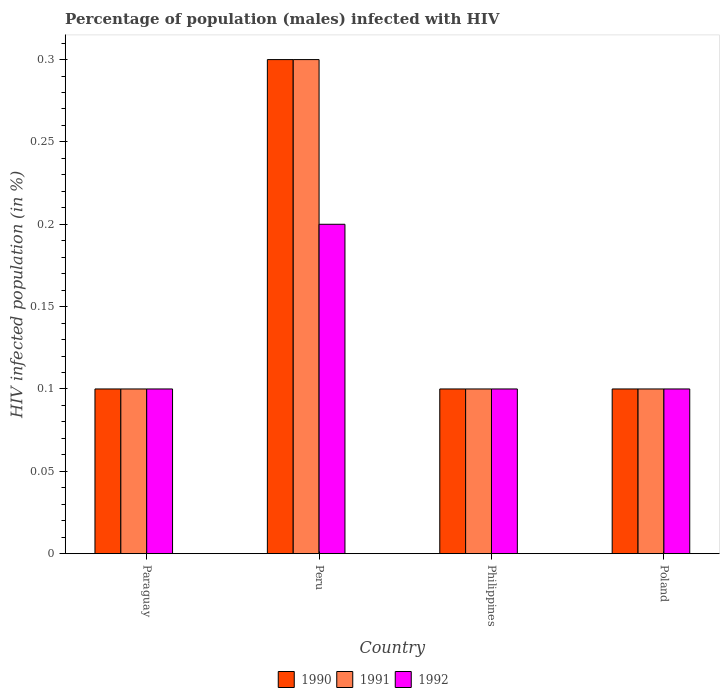How many different coloured bars are there?
Ensure brevity in your answer.  3. How many groups of bars are there?
Keep it short and to the point. 4. Are the number of bars per tick equal to the number of legend labels?
Keep it short and to the point. Yes. How many bars are there on the 3rd tick from the left?
Ensure brevity in your answer.  3. How many bars are there on the 4th tick from the right?
Offer a terse response. 3. What is the label of the 1st group of bars from the left?
Offer a terse response. Paraguay. In how many cases, is the number of bars for a given country not equal to the number of legend labels?
Your answer should be very brief. 0. What is the percentage of HIV infected male population in 1992 in Paraguay?
Offer a very short reply. 0.1. In which country was the percentage of HIV infected male population in 1990 minimum?
Your answer should be very brief. Paraguay. What is the difference between the percentage of HIV infected male population in 1992 in Peru and the percentage of HIV infected male population in 1990 in Philippines?
Make the answer very short. 0.1. What is the difference between the percentage of HIV infected male population of/in 1992 and percentage of HIV infected male population of/in 1990 in Poland?
Offer a terse response. 0. Is the percentage of HIV infected male population in 1991 in Paraguay less than that in Poland?
Give a very brief answer. No. Is the difference between the percentage of HIV infected male population in 1992 in Peru and Poland greater than the difference between the percentage of HIV infected male population in 1990 in Peru and Poland?
Provide a short and direct response. No. What is the difference between the highest and the second highest percentage of HIV infected male population in 1990?
Your answer should be very brief. 0.2. In how many countries, is the percentage of HIV infected male population in 1991 greater than the average percentage of HIV infected male population in 1991 taken over all countries?
Give a very brief answer. 1. Is the sum of the percentage of HIV infected male population in 1992 in Paraguay and Poland greater than the maximum percentage of HIV infected male population in 1990 across all countries?
Your answer should be compact. No. Is it the case that in every country, the sum of the percentage of HIV infected male population in 1992 and percentage of HIV infected male population in 1990 is greater than the percentage of HIV infected male population in 1991?
Keep it short and to the point. Yes. How many countries are there in the graph?
Provide a succinct answer. 4. What is the difference between two consecutive major ticks on the Y-axis?
Provide a succinct answer. 0.05. Are the values on the major ticks of Y-axis written in scientific E-notation?
Your answer should be compact. No. Does the graph contain any zero values?
Your response must be concise. No. How many legend labels are there?
Keep it short and to the point. 3. What is the title of the graph?
Your answer should be compact. Percentage of population (males) infected with HIV. What is the label or title of the Y-axis?
Offer a terse response. HIV infected population (in %). What is the HIV infected population (in %) of 1990 in Paraguay?
Your answer should be very brief. 0.1. What is the HIV infected population (in %) of 1992 in Peru?
Provide a short and direct response. 0.2. What is the HIV infected population (in %) of 1991 in Poland?
Your answer should be very brief. 0.1. What is the HIV infected population (in %) of 1992 in Poland?
Provide a short and direct response. 0.1. Across all countries, what is the maximum HIV infected population (in %) of 1990?
Provide a succinct answer. 0.3. Across all countries, what is the minimum HIV infected population (in %) of 1990?
Provide a short and direct response. 0.1. Across all countries, what is the minimum HIV infected population (in %) of 1992?
Your response must be concise. 0.1. What is the total HIV infected population (in %) of 1990 in the graph?
Offer a terse response. 0.6. What is the total HIV infected population (in %) in 1991 in the graph?
Keep it short and to the point. 0.6. What is the total HIV infected population (in %) in 1992 in the graph?
Ensure brevity in your answer.  0.5. What is the difference between the HIV infected population (in %) of 1990 in Paraguay and that in Peru?
Offer a very short reply. -0.2. What is the difference between the HIV infected population (in %) of 1990 in Paraguay and that in Philippines?
Your response must be concise. 0. What is the difference between the HIV infected population (in %) of 1991 in Paraguay and that in Philippines?
Provide a succinct answer. 0. What is the difference between the HIV infected population (in %) in 1992 in Paraguay and that in Philippines?
Provide a succinct answer. 0. What is the difference between the HIV infected population (in %) in 1990 in Peru and that in Philippines?
Provide a succinct answer. 0.2. What is the difference between the HIV infected population (in %) of 1990 in Peru and that in Poland?
Offer a terse response. 0.2. What is the difference between the HIV infected population (in %) of 1992 in Peru and that in Poland?
Provide a short and direct response. 0.1. What is the difference between the HIV infected population (in %) of 1990 in Philippines and that in Poland?
Ensure brevity in your answer.  0. What is the difference between the HIV infected population (in %) of 1991 in Paraguay and the HIV infected population (in %) of 1992 in Peru?
Your answer should be compact. -0.1. What is the difference between the HIV infected population (in %) of 1990 in Paraguay and the HIV infected population (in %) of 1992 in Philippines?
Ensure brevity in your answer.  0. What is the difference between the HIV infected population (in %) of 1991 in Paraguay and the HIV infected population (in %) of 1992 in Poland?
Ensure brevity in your answer.  0. What is the difference between the HIV infected population (in %) in 1990 in Peru and the HIV infected population (in %) in 1992 in Philippines?
Your answer should be very brief. 0.2. What is the difference between the HIV infected population (in %) in 1990 in Peru and the HIV infected population (in %) in 1992 in Poland?
Offer a terse response. 0.2. What is the difference between the HIV infected population (in %) in 1990 in Philippines and the HIV infected population (in %) in 1992 in Poland?
Ensure brevity in your answer.  0. What is the difference between the HIV infected population (in %) in 1990 and HIV infected population (in %) in 1991 in Paraguay?
Provide a succinct answer. 0. What is the difference between the HIV infected population (in %) in 1990 and HIV infected population (in %) in 1992 in Paraguay?
Give a very brief answer. 0. What is the difference between the HIV infected population (in %) in 1990 and HIV infected population (in %) in 1992 in Peru?
Ensure brevity in your answer.  0.1. What is the difference between the HIV infected population (in %) of 1990 and HIV infected population (in %) of 1991 in Philippines?
Your answer should be compact. 0. What is the difference between the HIV infected population (in %) of 1991 and HIV infected population (in %) of 1992 in Philippines?
Offer a very short reply. 0. What is the ratio of the HIV infected population (in %) of 1991 in Paraguay to that in Peru?
Offer a very short reply. 0.33. What is the ratio of the HIV infected population (in %) of 1990 in Paraguay to that in Philippines?
Keep it short and to the point. 1. What is the ratio of the HIV infected population (in %) in 1991 in Paraguay to that in Philippines?
Offer a very short reply. 1. What is the ratio of the HIV infected population (in %) in 1990 in Paraguay to that in Poland?
Your answer should be very brief. 1. What is the ratio of the HIV infected population (in %) in 1991 in Paraguay to that in Poland?
Keep it short and to the point. 1. What is the ratio of the HIV infected population (in %) in 1990 in Peru to that in Philippines?
Your answer should be very brief. 3. What is the ratio of the HIV infected population (in %) in 1991 in Peru to that in Philippines?
Offer a very short reply. 3. What is the ratio of the HIV infected population (in %) of 1992 in Peru to that in Poland?
Give a very brief answer. 2. What is the ratio of the HIV infected population (in %) of 1991 in Philippines to that in Poland?
Provide a succinct answer. 1. What is the ratio of the HIV infected population (in %) of 1992 in Philippines to that in Poland?
Ensure brevity in your answer.  1. What is the difference between the highest and the second highest HIV infected population (in %) in 1990?
Give a very brief answer. 0.2. What is the difference between the highest and the second highest HIV infected population (in %) in 1992?
Offer a very short reply. 0.1. What is the difference between the highest and the lowest HIV infected population (in %) in 1990?
Give a very brief answer. 0.2. 